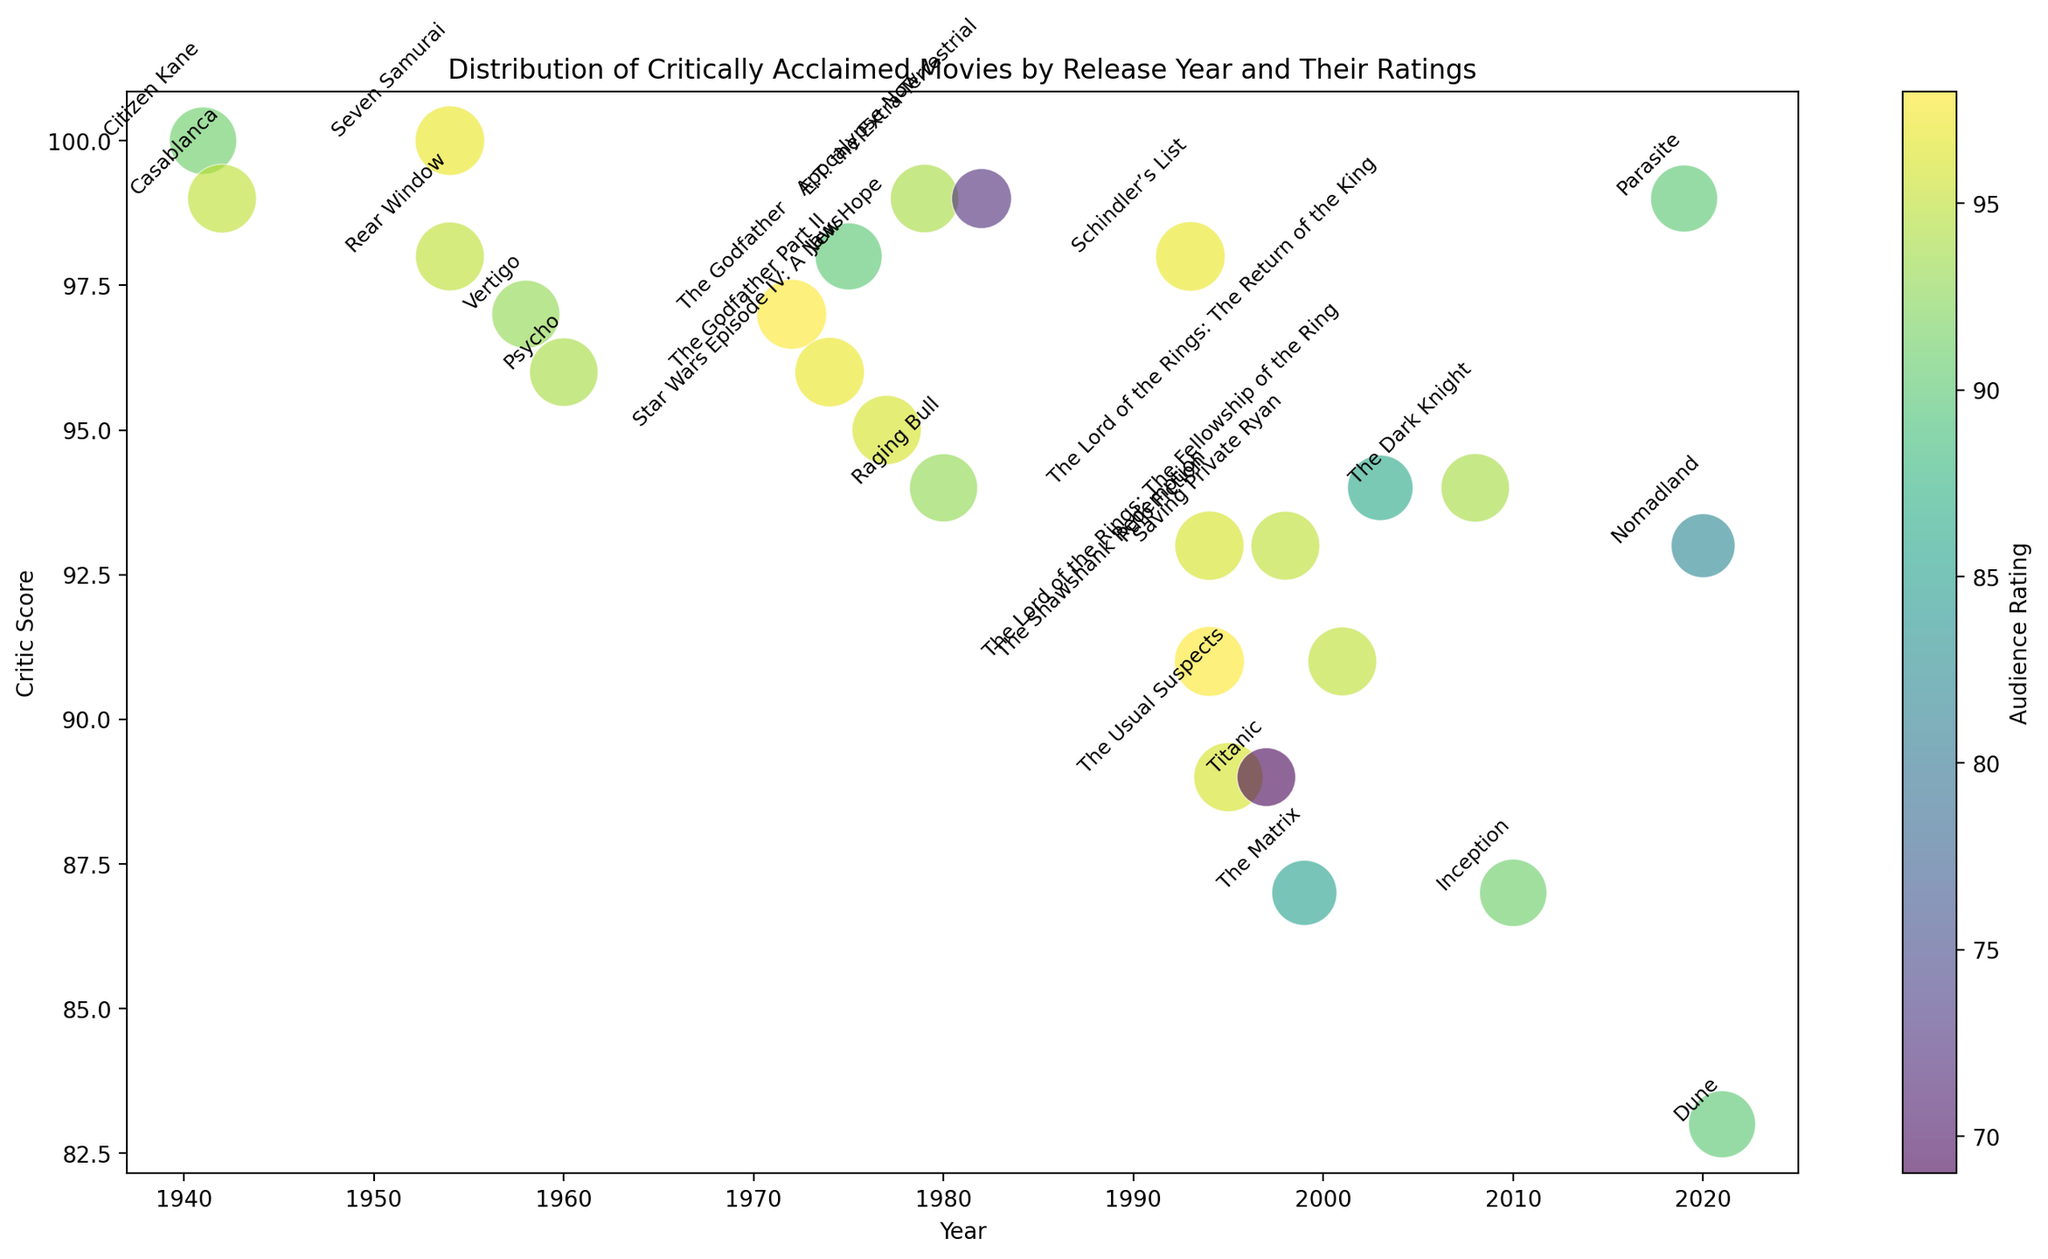Which movie has the highest audience rating? The audience rating is represented by the size of the bubbles. The movie with the largest bubble indicates the highest audience rating. Look for the biggest bubble and check the annotated movie title.
Answer: The Shawshank Redemption What is the critic score of the oldest movie on the chart? The years are plotted on the x-axis. Identify the leftmost plotted point which represents the oldest movie, and look up the corresponding critic score on the y-axis.
Answer: 100 (Citizen Kane) Between "Titanic" and "Inception," which one has a higher critic score? Locate the bubbles corresponding to "Titanic" and "Inception" by their annotations. Compare their positions on the y-axis, which indicates the critic scores.
Answer: Titanic Which movie from the 1970s has the highest audience rating? Find the bubbles within the x-axis range from 1970 to 1979. Then, look for the bubble in this range with the largest size and check the annotated title.
Answer: Star Wars Episode IV: A New Hope What is the average critic score of movies released in the 1990s? Identify the movies released in the 1990s ("Schindler’s List", "Pulp Fiction", "The Shawshank Redemption", "The Usual Suspects", "Titanic", "Saving Private Ryan", "The Matrix"). Sum their critic scores and divide by the number of these movies. (98 + 93 + 91 + 89 + 89 + 93 + 87) / 7
Answer: 91.4 Which decade has the most bubbles? Count the bubbles within each decade range on the x-axis (1940s, 1950s, 1960s, 1970s, 1980s, 1990s, 2000s, 2010s, 2020s). Identify the decade with the highest count.
Answer: 1990s What is the range of audience ratings for movies released in the 1980s? Identify the movies released in the 1980s ("Raging Bull", "E.T. the Extra-Terrestrial"). Note their audience ratings and find the difference between the highest and lowest values. 94 - 72
Answer: 22 Which 2000s movie has the smallest bubble? Locate the bubbles within the x-axis range from 2000 to 2009. Compare the bubble sizes in this range to find the smallest and check the annotated title.
Answer: The Lord of the Rings: The Return of the King How do the critic scores of "The Godfather" and "The Godfather Part II" compare? Locate the bubbles for "The Godfather" and "The Godfather Part II". Compare their y-axis positions, which indicates critic scores.
Answer: The Godfather is higher Is there any movie with both a critic score and an audience rating above 97? Check both axes for any bubbles at or above 97 on both y-axis (critic score) and bubble size (audience rating).
Answer: Yes (Schindler’s List, Seven Samurai) 